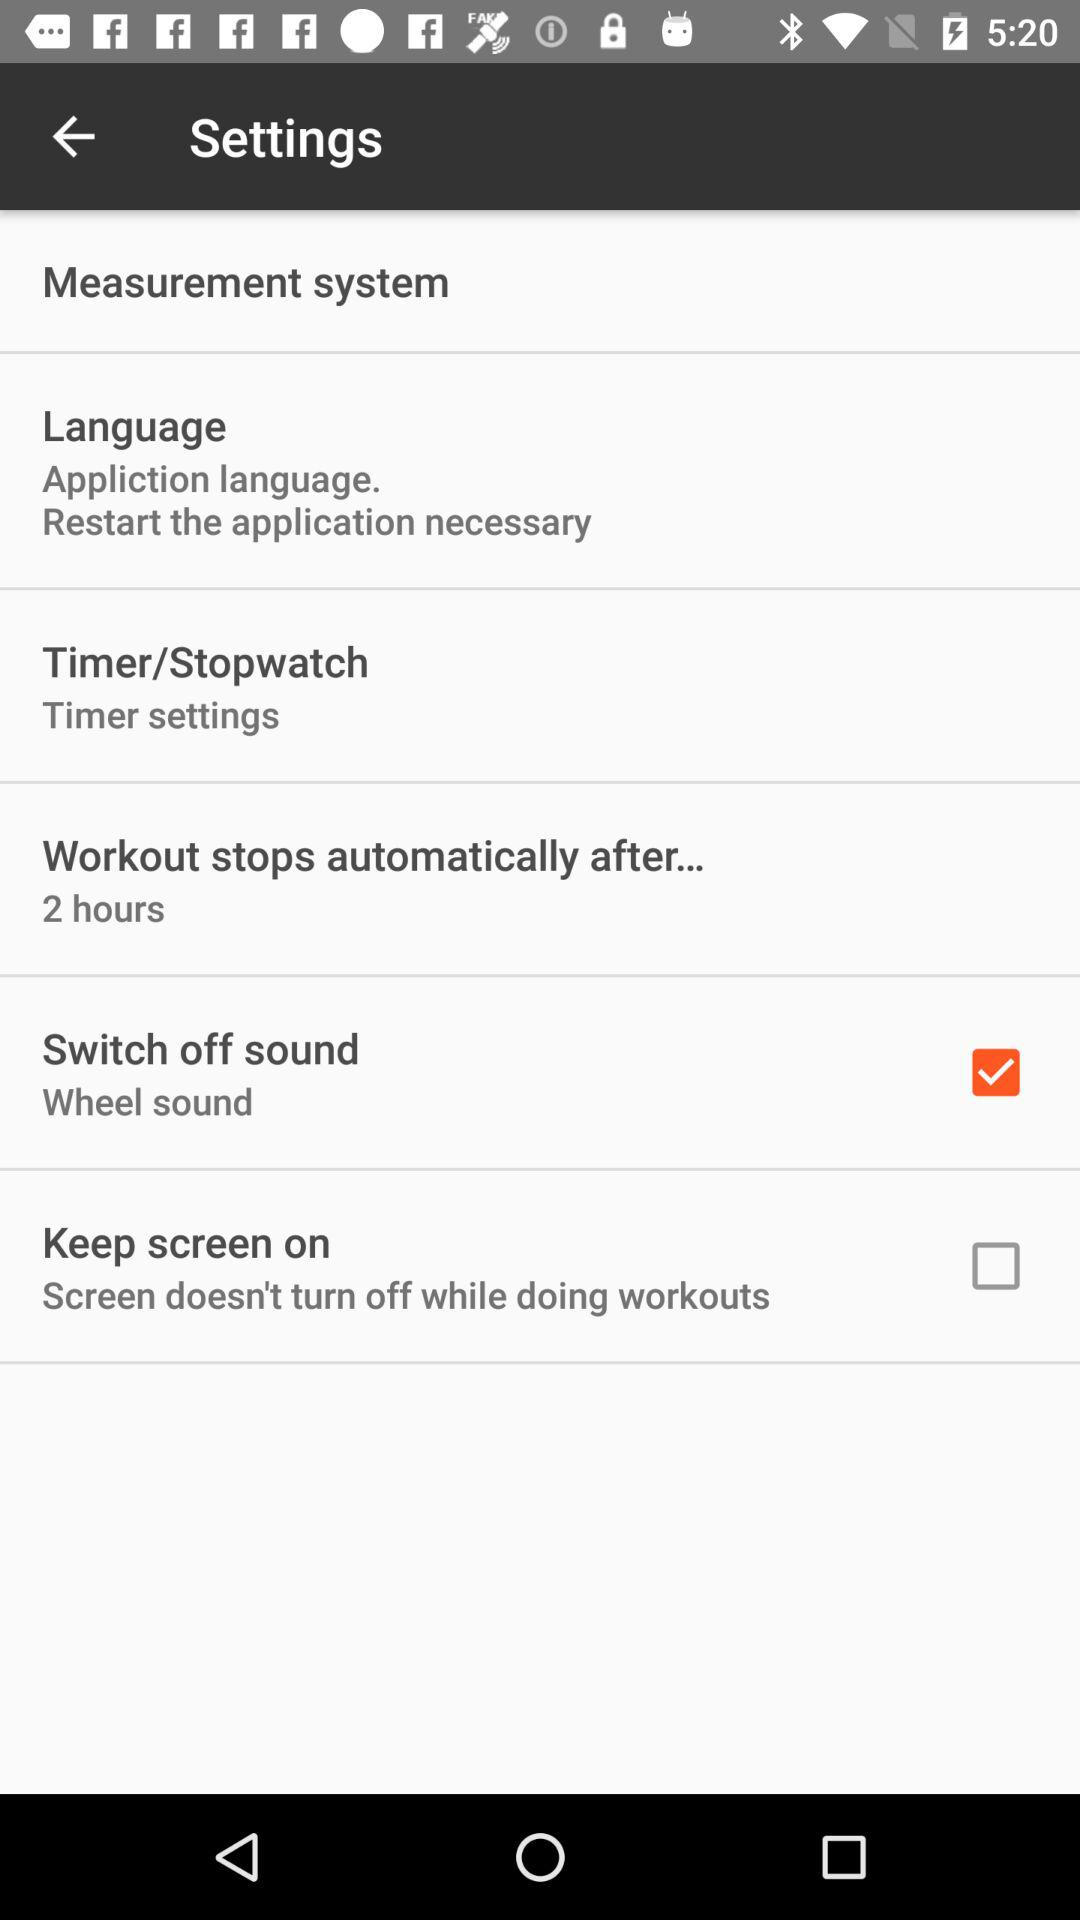After how much time will the workout stop automatically? The workout will stop automatically after 2 hours. 